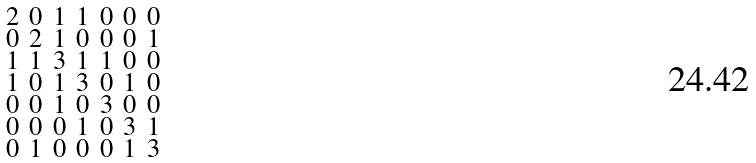Convert formula to latex. <formula><loc_0><loc_0><loc_500><loc_500>\begin{smallmatrix} 2 & 0 & 1 & 1 & 0 & 0 & 0 \\ 0 & 2 & 1 & 0 & 0 & 0 & 1 \\ 1 & 1 & 3 & 1 & 1 & 0 & 0 \\ 1 & 0 & 1 & 3 & 0 & 1 & 0 \\ 0 & 0 & 1 & 0 & 3 & 0 & 0 \\ 0 & 0 & 0 & 1 & 0 & 3 & 1 \\ 0 & 1 & 0 & 0 & 0 & 1 & 3 \end{smallmatrix}</formula> 